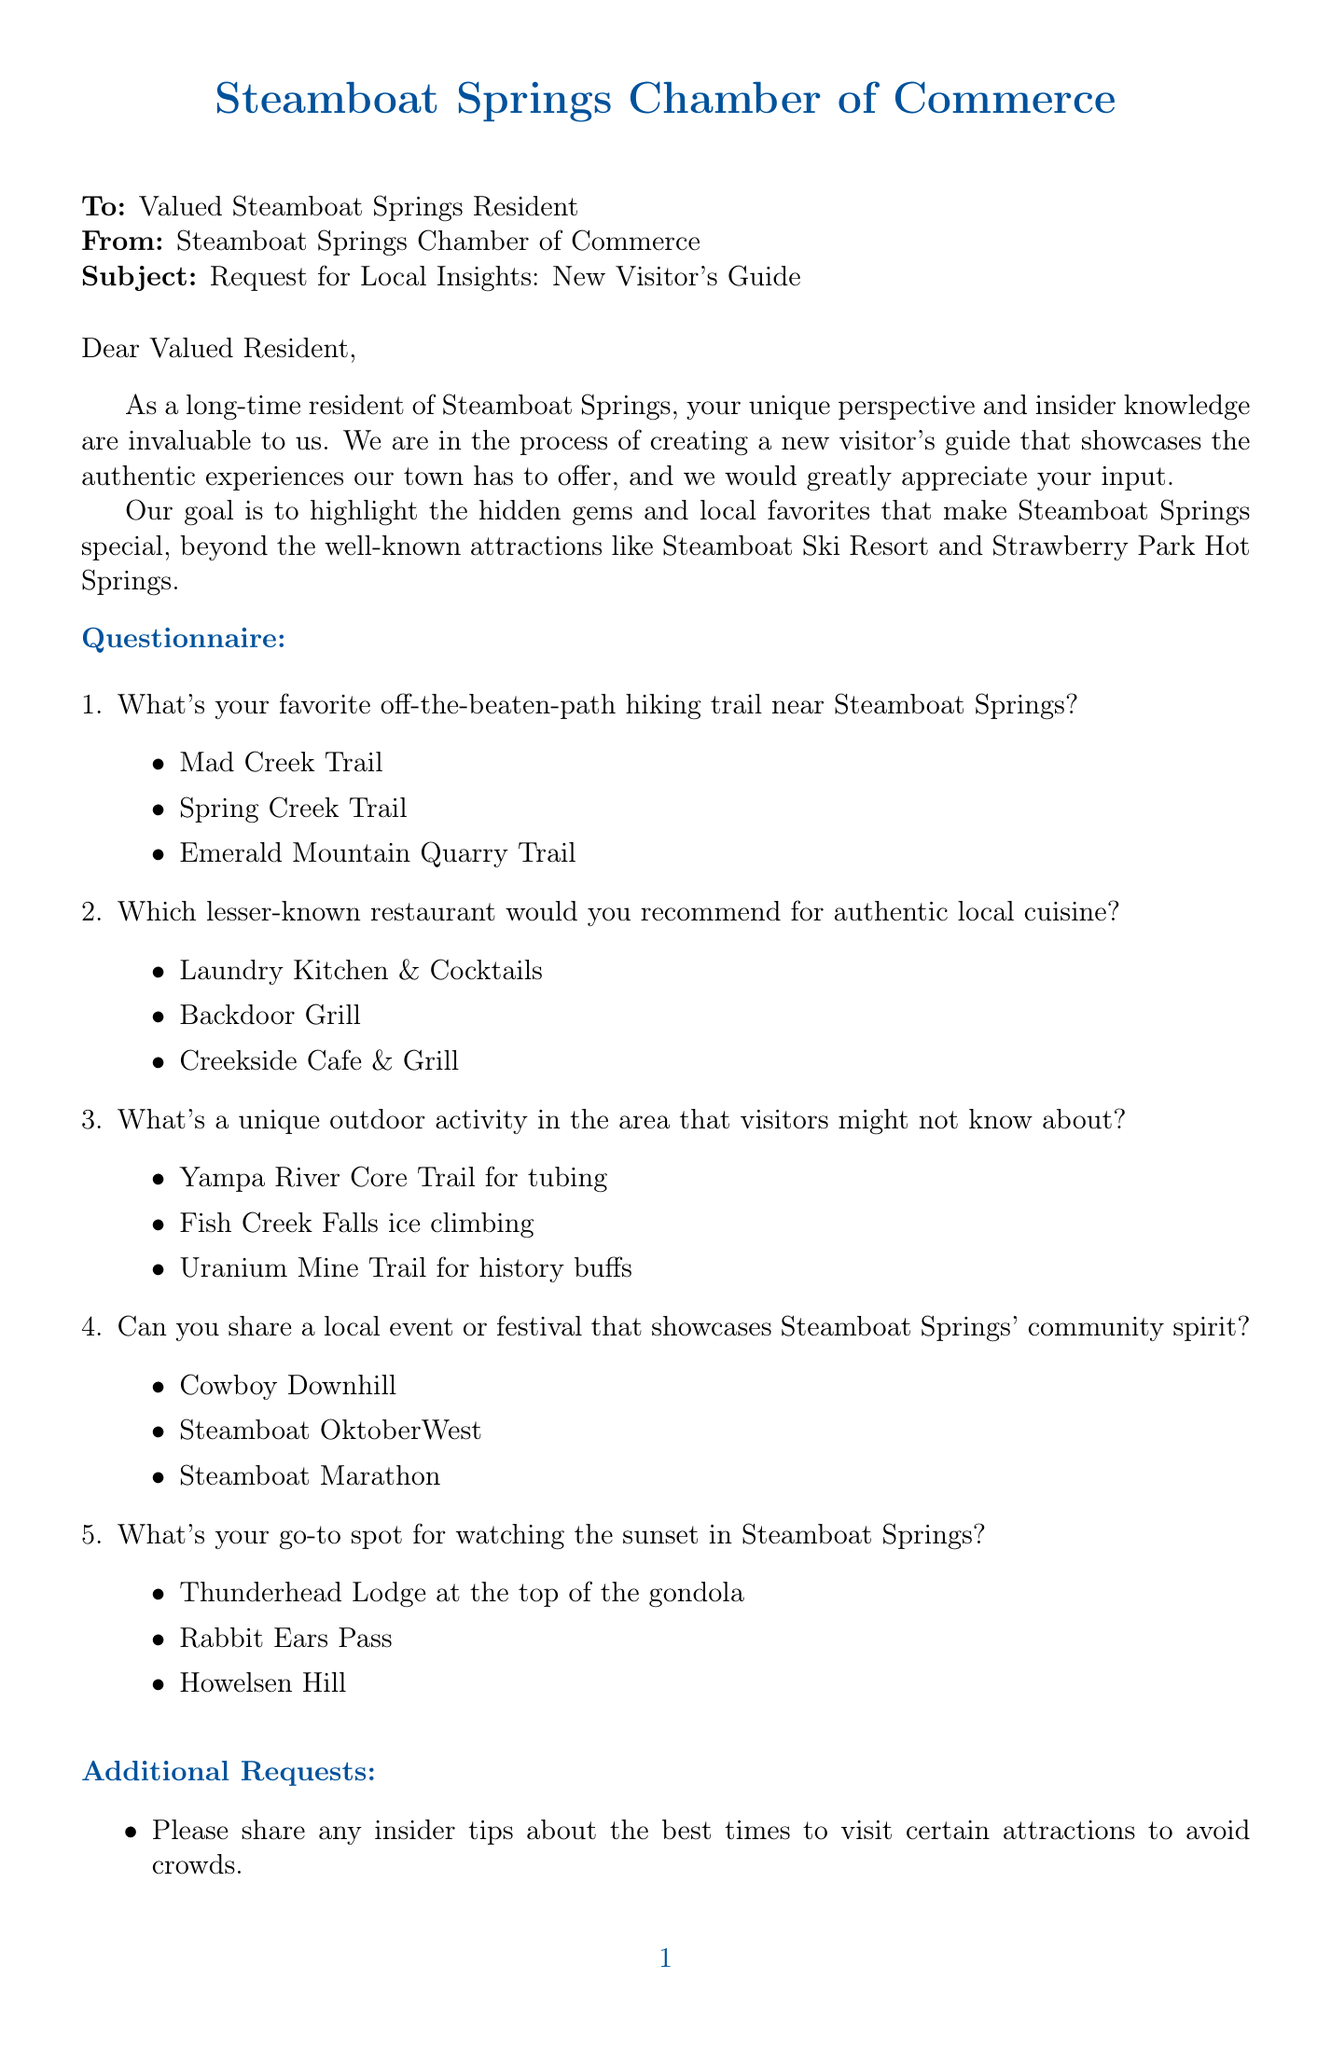What's the name of the person requesting local insights? The document mentions Sarah Johnson as the person making the request for insights.
Answer: Sarah Johnson What is the primary goal of the visitor's guide? The goal stated in the document is to highlight hidden gems and local favorites in Steamboat Springs.
Answer: Highlight hidden gems and local favorites What event is specifically mentioned as a local festival? Among the festivals mentioned in the questionnaire, Cowboy Downhill is listed, highlighting community spirit.
Answer: Cowboy Downhill How many hiking trails are suggested in the questionnaire? The document lists three hiking trail options in the questionnaire, making it a total of three.
Answer: Three What email address is provided for contact? The email address for Sarah Johnson, as noted in the contact information, is included in the document.
Answer: sarah.johnson@steamboatchamber.com What attraction is mentioned as a well-known location in Steamboat Springs? The document identifies Steamboat Ski Resort as a notable attraction, emphasizing the need to showcase lesser-known sites.
Answer: Steamboat Ski Resort Which restaurant is suggested for authentic local cuisine? The document lists three options, and one of them is Laundry Kitchen & Cocktails, recommending it for local cuisine.
Answer: Laundry Kitchen & Cocktails What unique outdoor activity is highlighted? Fish Creek Falls ice climbing is noted as a unique outdoor activity in the document that visitors might not know about.
Answer: Fish Creek Falls ice climbing 